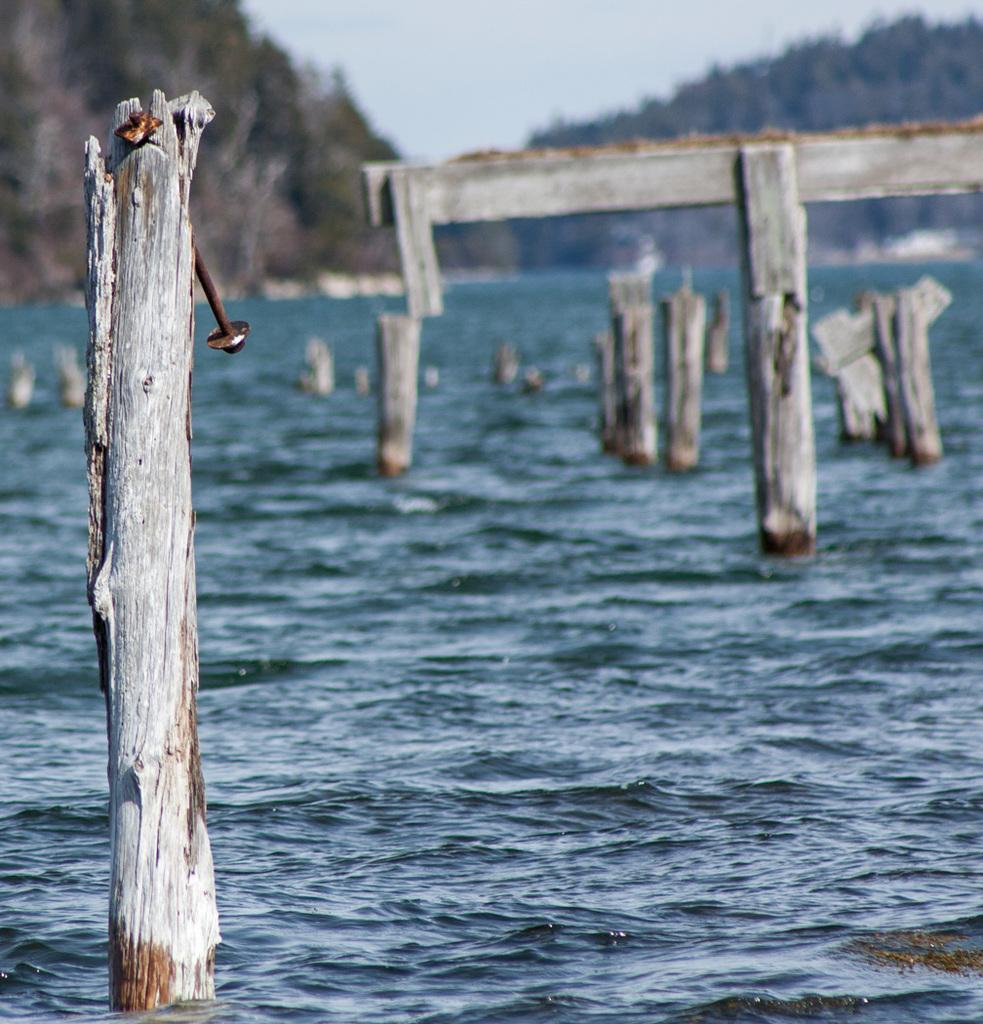What objects are in the water in the image? There are wooden logs in the water in the image. What can be seen in the distance in the image? Mountains are visible in the background of the image. How would you describe the clarity of the image? The image is blurred. What verse is being recited by the kettle in the image? There is no kettle present in the image, and therefore no verse being recited. 